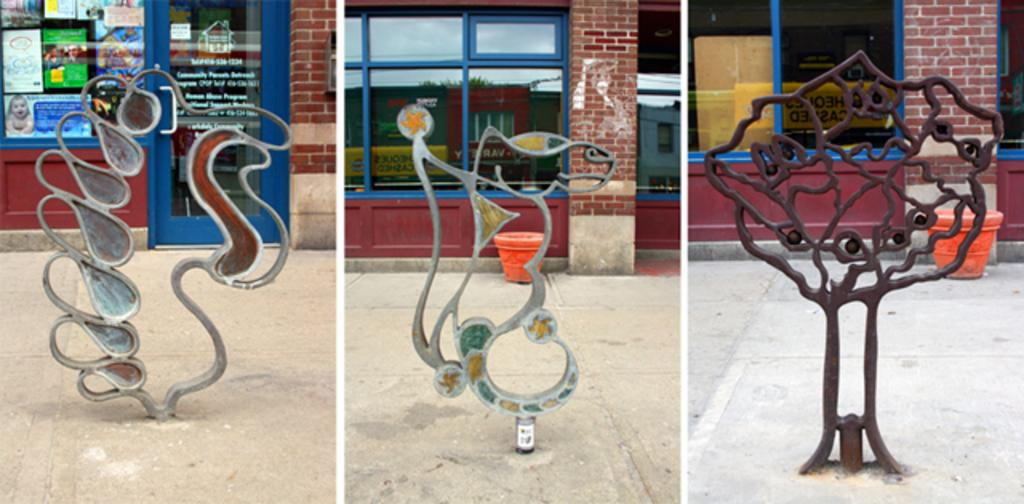How many images are present in the picture? There are three images in the picture. What do the images have in common? Each image contains a symbolized structure made up of iron. What can be seen in the background of each image? There is a wall in the background of each image. Can you see the tongue of the person smiling in the image? There is no person or smile present in the image; it contains symbolized iron structures and a wall in the background. 